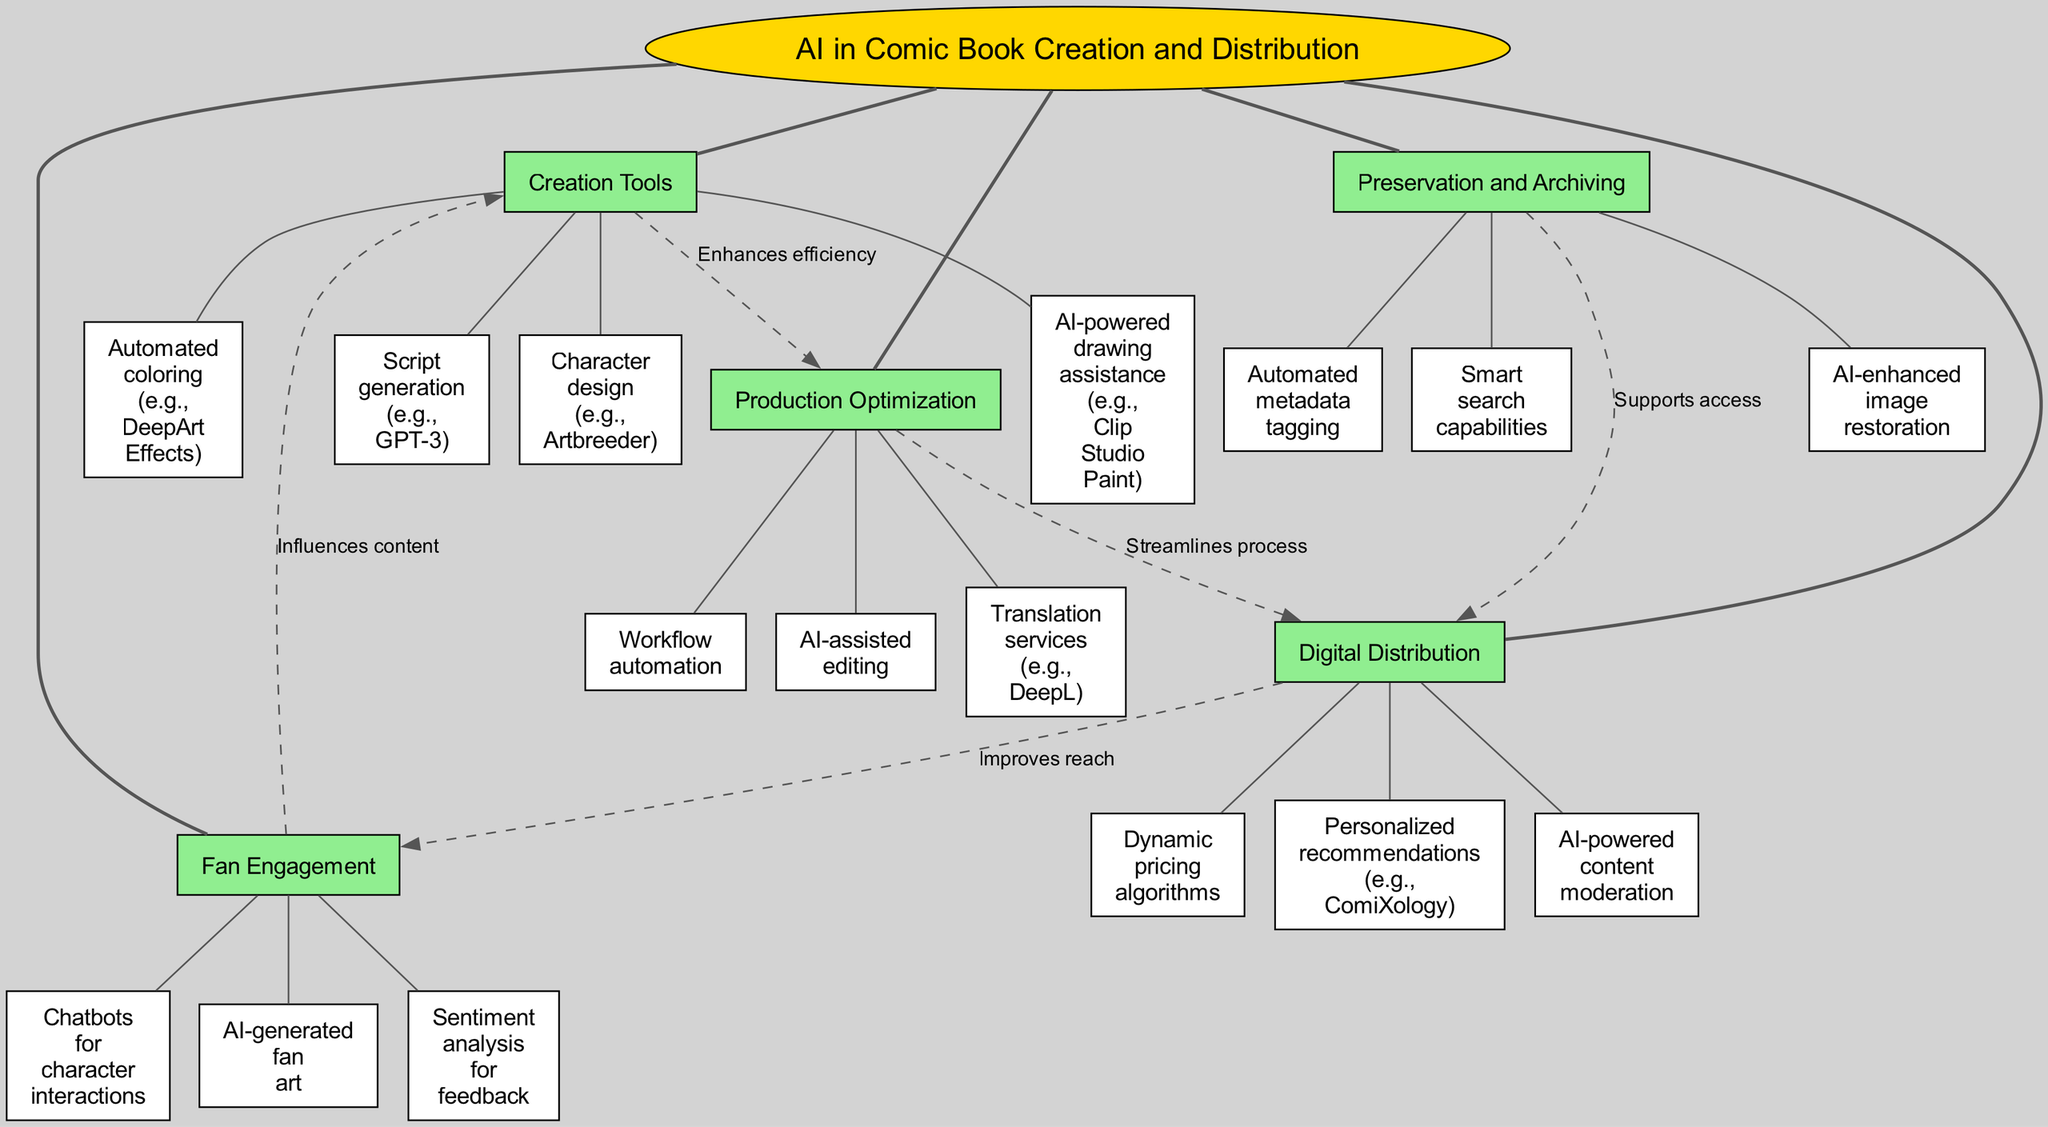What is the central concept of the diagram? The central concept is labeled as "AI in Comic Book Creation and Distribution." It's the primary node from which all main branches extend.
Answer: AI in Comic Book Creation and Distribution How many main branches does the diagram have? The diagram has five main branches, which are Creation Tools, Production Optimization, Digital Distribution, Fan Engagement, and Preservation and Archiving.
Answer: 5 Which branch includes automated metadata tagging? Automated metadata tagging is a sub-branch under the Preservation and Archiving main branch. By examining the branches, it is evident where each sub-branch is categorized.
Answer: Preservation and Archiving What label connects Production Optimization and Digital Distribution? The label connecting Production Optimization and Digital Distribution is "Streamlines process," indicating a relationship that focuses on improving the process flow between these two branches.
Answer: Streamlines process Which sub-branch is linked to Chatbots for character interactions? Chatbots for character interactions is linked to the Fan Engagement branch as a sub-branch. The relationship can be determined by tracing back to the main branch to which it belongs.
Answer: Fan Engagement What enhances efficiency in the diagram? The connection from Creation Tools to Production Optimization is labeled as "Enhances efficiency," suggesting that tools in Creation contribute to better optimization in production.
Answer: Enhances efficiency Which element supports access in Digital Distribution? AI-enhanced image restoration from the Preservation and Archiving branch supports the access efforts in Digital Distribution, as indicated by the connection shown in the diagram.
Answer: AI-enhanced image restoration How does Fan Engagement influence Creation Tools? It is shown through the dashed line labeled "Influences content" connecting Fan Engagement to Creation Tools, indicating that feedback from fan engagement can shape the creation tools used in comic book production.
Answer: Influences content What is a primary factor that improves reach according to the diagram? The label "Improves reach" connects Digital Distribution to Fan Engagement, showing that distribution methods play a key role in engaging fans more effectively.
Answer: Improves reach 